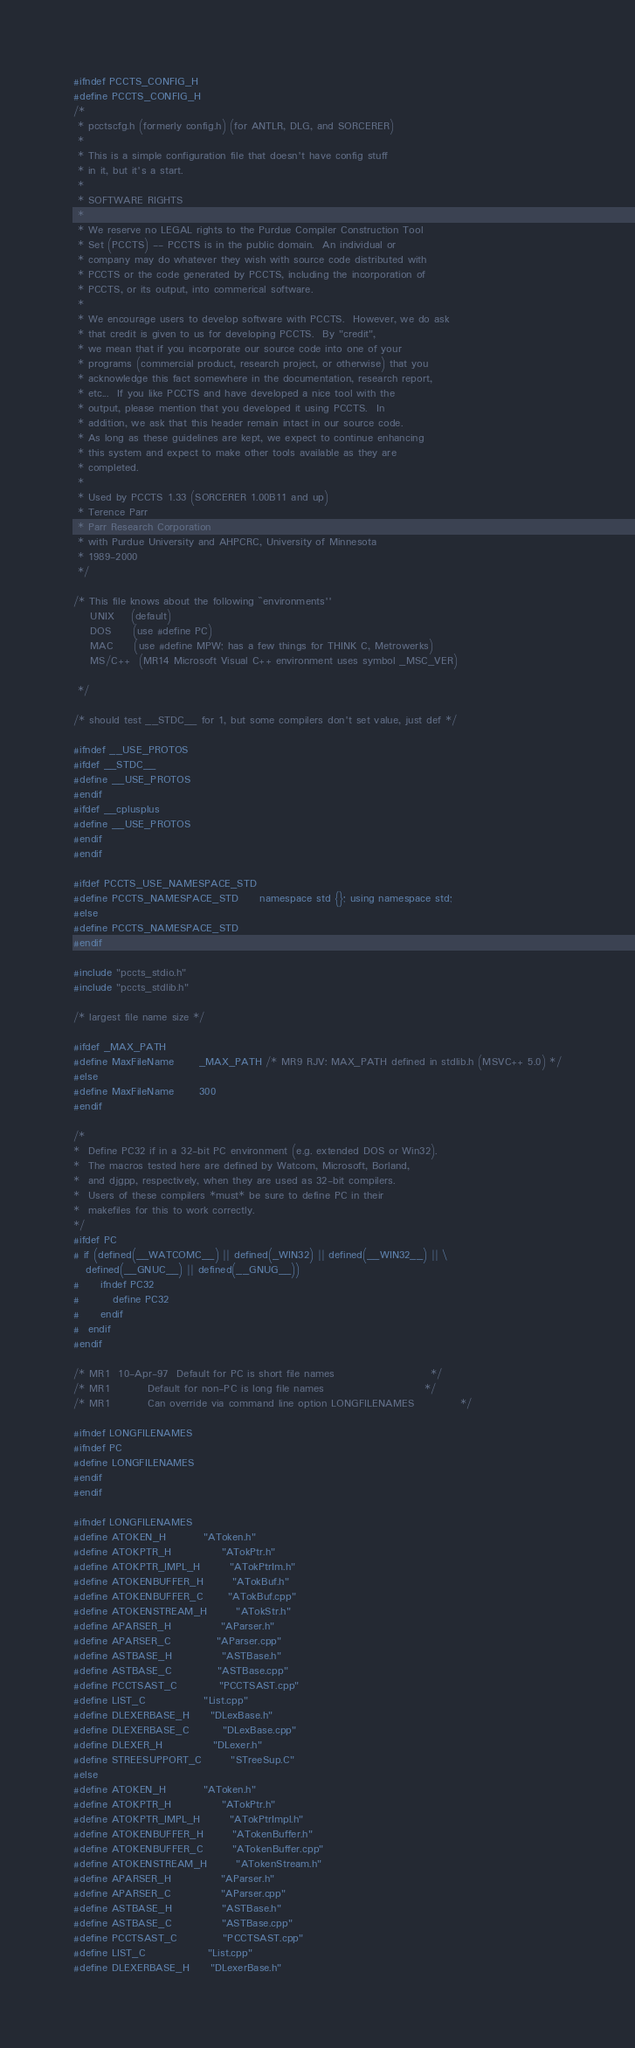<code> <loc_0><loc_0><loc_500><loc_500><_C_>#ifndef PCCTS_CONFIG_H
#define PCCTS_CONFIG_H
/*
 * pcctscfg.h (formerly config.h) (for ANTLR, DLG, and SORCERER)
 *
 * This is a simple configuration file that doesn't have config stuff
 * in it, but it's a start.
 *
 * SOFTWARE RIGHTS
 *
 * We reserve no LEGAL rights to the Purdue Compiler Construction Tool
 * Set (PCCTS) -- PCCTS is in the public domain.  An individual or
 * company may do whatever they wish with source code distributed with
 * PCCTS or the code generated by PCCTS, including the incorporation of
 * PCCTS, or its output, into commerical software.
 *
 * We encourage users to develop software with PCCTS.  However, we do ask
 * that credit is given to us for developing PCCTS.  By "credit",
 * we mean that if you incorporate our source code into one of your
 * programs (commercial product, research project, or otherwise) that you
 * acknowledge this fact somewhere in the documentation, research report,
 * etc...  If you like PCCTS and have developed a nice tool with the
 * output, please mention that you developed it using PCCTS.  In
 * addition, we ask that this header remain intact in our source code.
 * As long as these guidelines are kept, we expect to continue enhancing
 * this system and expect to make other tools available as they are
 * completed.
 *
 * Used by PCCTS 1.33 (SORCERER 1.00B11 and up)
 * Terence Parr
 * Parr Research Corporation
 * with Purdue University and AHPCRC, University of Minnesota
 * 1989-2000
 */

/* This file knows about the following ``environments''
	UNIX    (default)
	DOS     (use #define PC)
	MAC     (use #define MPW; has a few things for THINK C, Metrowerks)
    MS/C++  (MR14 Microsoft Visual C++ environment uses symbol _MSC_VER)

 */

/* should test __STDC__ for 1, but some compilers don't set value, just def */

#ifndef __USE_PROTOS
#ifdef __STDC__
#define __USE_PROTOS
#endif
#ifdef __cplusplus
#define __USE_PROTOS
#endif
#endif

#ifdef PCCTS_USE_NAMESPACE_STD
#define PCCTS_NAMESPACE_STD     namespace std {}; using namespace std;
#else
#define PCCTS_NAMESPACE_STD
#endif

#include "pccts_stdio.h"
#include "pccts_stdlib.h"

/* largest file name size */

#ifdef _MAX_PATH
#define MaxFileName		_MAX_PATH /* MR9 RJV: MAX_PATH defined in stdlib.h (MSVC++ 5.0) */
#else
#define MaxFileName		300
#endif

/*
*  Define PC32 if in a 32-bit PC environment (e.g. extended DOS or Win32).
*  The macros tested here are defined by Watcom, Microsoft, Borland,
*  and djgpp, respectively, when they are used as 32-bit compilers.
*  Users of these compilers *must* be sure to define PC in their
*  makefiles for this to work correctly.
*/
#ifdef PC
# if (defined(__WATCOMC__) || defined(_WIN32) || defined(__WIN32__) || \
   defined(__GNUC__) || defined(__GNUG__))
#     ifndef PC32
#        define PC32
#     endif
#  endif
#endif

/* MR1  10-Apr-97  Default for PC is short file names			            */
/* MR1		   Default for non-PC is long file names                		*/
/* MR1		   Can override via command line option LONGFILENAMES           */

#ifndef LONGFILENAMES
#ifndef PC
#define LONGFILENAMES
#endif
#endif

#ifndef LONGFILENAMES
#define ATOKEN_H			"AToken.h"
#define ATOKPTR_H			"ATokPtr.h"
#define ATOKPTR_IMPL_H		"ATokPtrIm.h"
#define ATOKENBUFFER_H		"ATokBuf.h"
#define ATOKENBUFFER_C      "ATokBuf.cpp"
#define ATOKENSTREAM_H		"ATokStr.h"
#define APARSER_H			"AParser.h"
#define APARSER_C           "AParser.cpp"
#define ASTBASE_H			"ASTBase.h"
#define ASTBASE_C           "ASTBase.cpp"
#define PCCTSAST_C          "PCCTSAST.cpp"
#define LIST_C              "List.cpp"
#define DLEXERBASE_H		"DLexBase.h"
#define DLEXERBASE_C        "DLexBase.cpp"
#define DLEXER_H            "DLexer.h"
#define STREESUPPORT_C		"STreeSup.C"
#else
#define ATOKEN_H			"AToken.h"
#define ATOKPTR_H			"ATokPtr.h"
#define ATOKPTR_IMPL_H		"ATokPtrImpl.h"
#define ATOKENBUFFER_H		"ATokenBuffer.h"
#define ATOKENBUFFER_C		"ATokenBuffer.cpp"
#define ATOKENSTREAM_H		"ATokenStream.h"
#define APARSER_H			"AParser.h"
#define APARSER_C			"AParser.cpp"
#define ASTBASE_H			"ASTBase.h"
#define ASTBASE_C		    "ASTBase.cpp"
#define PCCTSAST_C			"PCCTSAST.cpp"
#define LIST_C				"List.cpp"
#define DLEXERBASE_H		"DLexerBase.h"</code> 